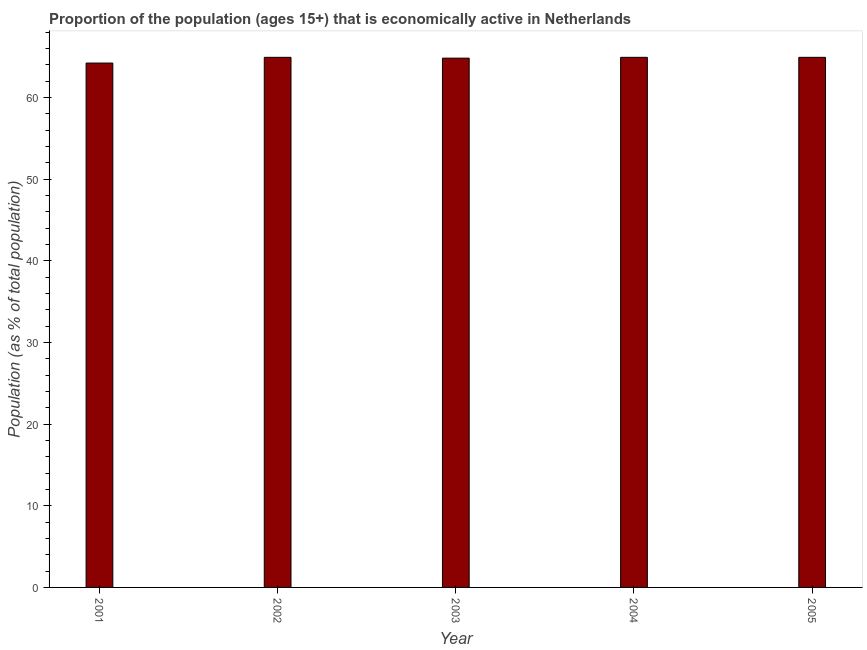Does the graph contain grids?
Make the answer very short. No. What is the title of the graph?
Your answer should be compact. Proportion of the population (ages 15+) that is economically active in Netherlands. What is the label or title of the Y-axis?
Provide a short and direct response. Population (as % of total population). What is the percentage of economically active population in 2002?
Offer a very short reply. 64.9. Across all years, what is the maximum percentage of economically active population?
Your answer should be very brief. 64.9. Across all years, what is the minimum percentage of economically active population?
Give a very brief answer. 64.2. What is the sum of the percentage of economically active population?
Your answer should be compact. 323.7. What is the average percentage of economically active population per year?
Ensure brevity in your answer.  64.74. What is the median percentage of economically active population?
Make the answer very short. 64.9. Do a majority of the years between 2003 and 2005 (inclusive) have percentage of economically active population greater than 20 %?
Provide a succinct answer. Yes. What is the ratio of the percentage of economically active population in 2003 to that in 2004?
Offer a terse response. 1. Is the sum of the percentage of economically active population in 2002 and 2003 greater than the maximum percentage of economically active population across all years?
Offer a terse response. Yes. What is the difference between the highest and the lowest percentage of economically active population?
Your response must be concise. 0.7. In how many years, is the percentage of economically active population greater than the average percentage of economically active population taken over all years?
Your response must be concise. 4. How many years are there in the graph?
Make the answer very short. 5. What is the Population (as % of total population) in 2001?
Your answer should be very brief. 64.2. What is the Population (as % of total population) in 2002?
Ensure brevity in your answer.  64.9. What is the Population (as % of total population) of 2003?
Your answer should be very brief. 64.8. What is the Population (as % of total population) of 2004?
Your answer should be very brief. 64.9. What is the Population (as % of total population) in 2005?
Your answer should be compact. 64.9. What is the difference between the Population (as % of total population) in 2001 and 2002?
Offer a very short reply. -0.7. What is the difference between the Population (as % of total population) in 2001 and 2003?
Offer a very short reply. -0.6. What is the difference between the Population (as % of total population) in 2001 and 2004?
Give a very brief answer. -0.7. What is the difference between the Population (as % of total population) in 2002 and 2003?
Provide a short and direct response. 0.1. What is the difference between the Population (as % of total population) in 2002 and 2004?
Your response must be concise. 0. What is the difference between the Population (as % of total population) in 2002 and 2005?
Offer a very short reply. 0. What is the difference between the Population (as % of total population) in 2003 and 2005?
Give a very brief answer. -0.1. What is the ratio of the Population (as % of total population) in 2001 to that in 2002?
Provide a succinct answer. 0.99. What is the ratio of the Population (as % of total population) in 2001 to that in 2005?
Provide a short and direct response. 0.99. What is the ratio of the Population (as % of total population) in 2002 to that in 2003?
Give a very brief answer. 1. What is the ratio of the Population (as % of total population) in 2004 to that in 2005?
Offer a very short reply. 1. 